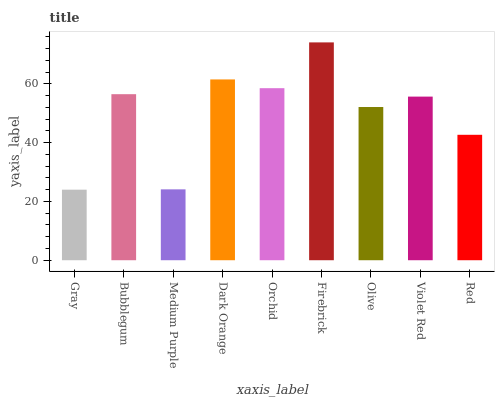Is Bubblegum the minimum?
Answer yes or no. No. Is Bubblegum the maximum?
Answer yes or no. No. Is Bubblegum greater than Gray?
Answer yes or no. Yes. Is Gray less than Bubblegum?
Answer yes or no. Yes. Is Gray greater than Bubblegum?
Answer yes or no. No. Is Bubblegum less than Gray?
Answer yes or no. No. Is Violet Red the high median?
Answer yes or no. Yes. Is Violet Red the low median?
Answer yes or no. Yes. Is Red the high median?
Answer yes or no. No. Is Dark Orange the low median?
Answer yes or no. No. 